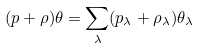<formula> <loc_0><loc_0><loc_500><loc_500>( p + \rho ) \theta = \sum _ { \lambda } ( p _ { \lambda } + \rho _ { \lambda } ) \theta _ { \lambda }</formula> 